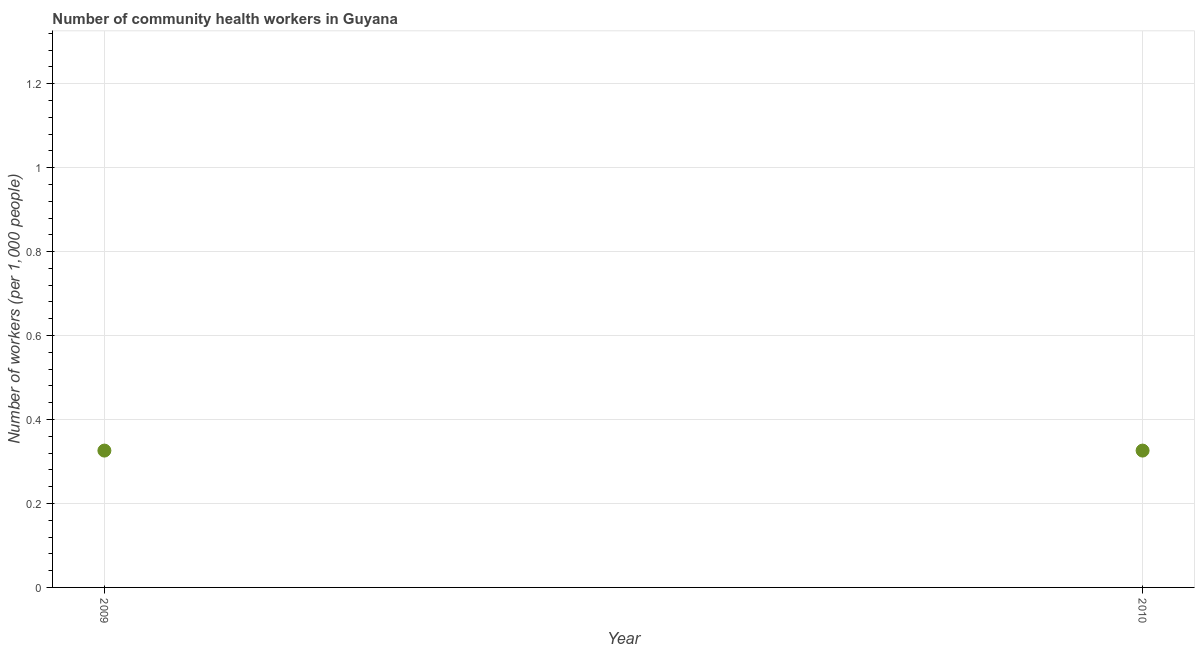What is the number of community health workers in 2010?
Your response must be concise. 0.33. Across all years, what is the maximum number of community health workers?
Your answer should be compact. 0.33. Across all years, what is the minimum number of community health workers?
Your response must be concise. 0.33. In which year was the number of community health workers minimum?
Your answer should be very brief. 2009. What is the sum of the number of community health workers?
Your answer should be very brief. 0.65. What is the average number of community health workers per year?
Offer a terse response. 0.33. What is the median number of community health workers?
Offer a very short reply. 0.33. In how many years, is the number of community health workers greater than 0.9600000000000001 ?
Make the answer very short. 0. What is the ratio of the number of community health workers in 2009 to that in 2010?
Give a very brief answer. 1. Is the number of community health workers in 2009 less than that in 2010?
Keep it short and to the point. No. In how many years, is the number of community health workers greater than the average number of community health workers taken over all years?
Offer a terse response. 0. How many dotlines are there?
Keep it short and to the point. 1. What is the difference between two consecutive major ticks on the Y-axis?
Provide a short and direct response. 0.2. Are the values on the major ticks of Y-axis written in scientific E-notation?
Offer a very short reply. No. Does the graph contain any zero values?
Offer a terse response. No. What is the title of the graph?
Keep it short and to the point. Number of community health workers in Guyana. What is the label or title of the Y-axis?
Make the answer very short. Number of workers (per 1,0 people). What is the Number of workers (per 1,000 people) in 2009?
Keep it short and to the point. 0.33. What is the Number of workers (per 1,000 people) in 2010?
Your answer should be compact. 0.33. What is the difference between the Number of workers (per 1,000 people) in 2009 and 2010?
Offer a terse response. 0. 